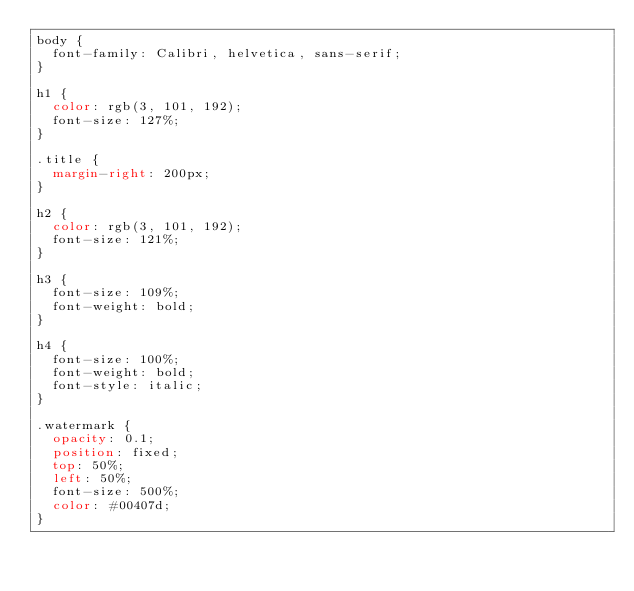<code> <loc_0><loc_0><loc_500><loc_500><_CSS_>body {
  font-family: Calibri, helvetica, sans-serif;
}

h1 {
  color: rgb(3, 101, 192);
  font-size: 127%;
}

.title {
  margin-right: 200px;
}

h2 {
  color: rgb(3, 101, 192);
  font-size: 121%;
}

h3 {
  font-size: 109%;
  font-weight: bold;
}

h4 {
  font-size: 100%;
  font-weight: bold;
  font-style: italic;
}

.watermark {
  opacity: 0.1;
  position: fixed;
  top: 50%;
  left: 50%;
  font-size: 500%;
  color: #00407d;
}
</code> 